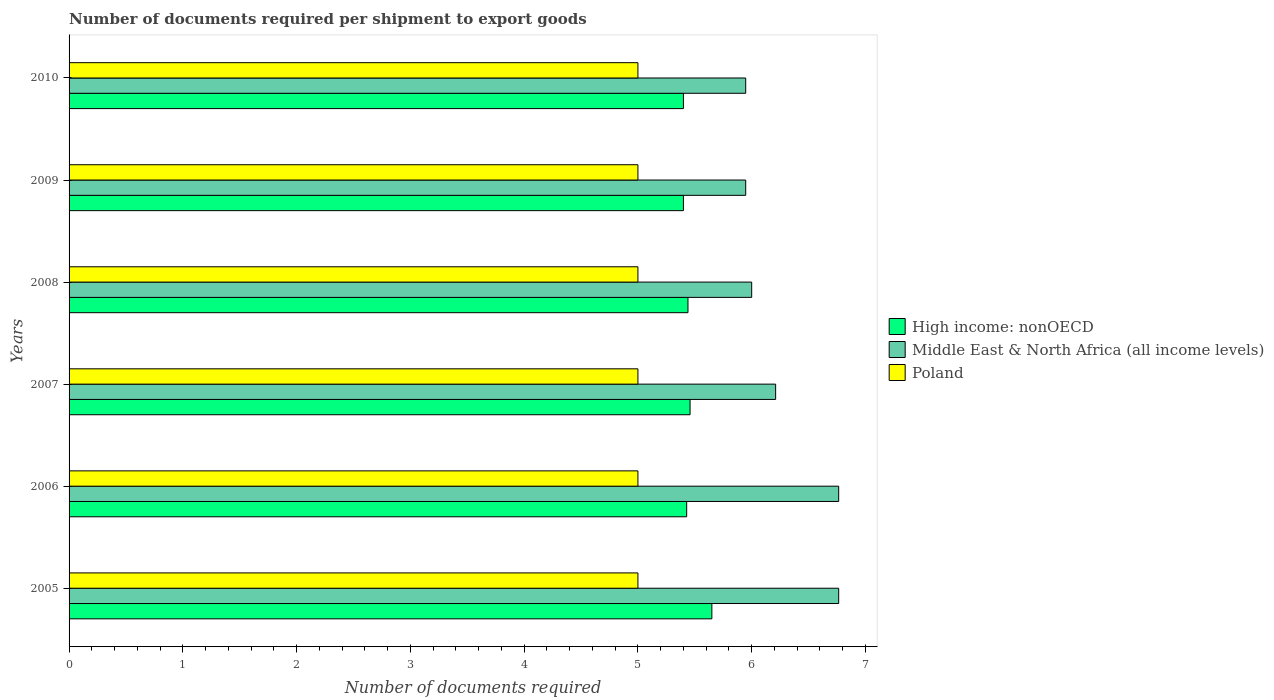How many groups of bars are there?
Your answer should be very brief. 6. Are the number of bars on each tick of the Y-axis equal?
Make the answer very short. Yes. How many bars are there on the 1st tick from the bottom?
Provide a succinct answer. 3. What is the number of documents required per shipment to export goods in High income: nonOECD in 2005?
Provide a short and direct response. 5.65. Across all years, what is the maximum number of documents required per shipment to export goods in Middle East & North Africa (all income levels)?
Your response must be concise. 6.76. Across all years, what is the minimum number of documents required per shipment to export goods in Poland?
Make the answer very short. 5. What is the total number of documents required per shipment to export goods in High income: nonOECD in the graph?
Your response must be concise. 32.78. What is the difference between the number of documents required per shipment to export goods in Poland in 2010 and the number of documents required per shipment to export goods in High income: nonOECD in 2005?
Your response must be concise. -0.65. What is the average number of documents required per shipment to export goods in High income: nonOECD per year?
Your answer should be compact. 5.46. In the year 2008, what is the difference between the number of documents required per shipment to export goods in High income: nonOECD and number of documents required per shipment to export goods in Middle East & North Africa (all income levels)?
Offer a very short reply. -0.56. What is the ratio of the number of documents required per shipment to export goods in Middle East & North Africa (all income levels) in 2007 to that in 2008?
Make the answer very short. 1.04. Is the sum of the number of documents required per shipment to export goods in Poland in 2006 and 2009 greater than the maximum number of documents required per shipment to export goods in Middle East & North Africa (all income levels) across all years?
Offer a very short reply. Yes. Is it the case that in every year, the sum of the number of documents required per shipment to export goods in Middle East & North Africa (all income levels) and number of documents required per shipment to export goods in Poland is greater than the number of documents required per shipment to export goods in High income: nonOECD?
Offer a terse response. Yes. Are all the bars in the graph horizontal?
Provide a short and direct response. Yes. How many years are there in the graph?
Provide a succinct answer. 6. Does the graph contain grids?
Offer a terse response. No. How many legend labels are there?
Provide a succinct answer. 3. What is the title of the graph?
Give a very brief answer. Number of documents required per shipment to export goods. Does "Seychelles" appear as one of the legend labels in the graph?
Your answer should be compact. No. What is the label or title of the X-axis?
Your answer should be compact. Number of documents required. What is the Number of documents required in High income: nonOECD in 2005?
Provide a short and direct response. 5.65. What is the Number of documents required in Middle East & North Africa (all income levels) in 2005?
Offer a terse response. 6.76. What is the Number of documents required in Poland in 2005?
Provide a short and direct response. 5. What is the Number of documents required of High income: nonOECD in 2006?
Your answer should be compact. 5.43. What is the Number of documents required in Middle East & North Africa (all income levels) in 2006?
Your answer should be very brief. 6.76. What is the Number of documents required of Poland in 2006?
Your response must be concise. 5. What is the Number of documents required of High income: nonOECD in 2007?
Provide a succinct answer. 5.46. What is the Number of documents required of Middle East & North Africa (all income levels) in 2007?
Give a very brief answer. 6.21. What is the Number of documents required in Poland in 2007?
Ensure brevity in your answer.  5. What is the Number of documents required in High income: nonOECD in 2008?
Give a very brief answer. 5.44. What is the Number of documents required of High income: nonOECD in 2009?
Offer a very short reply. 5.4. What is the Number of documents required in Middle East & North Africa (all income levels) in 2009?
Offer a very short reply. 5.95. What is the Number of documents required in Poland in 2009?
Offer a terse response. 5. What is the Number of documents required of Middle East & North Africa (all income levels) in 2010?
Give a very brief answer. 5.95. What is the Number of documents required of Poland in 2010?
Make the answer very short. 5. Across all years, what is the maximum Number of documents required in High income: nonOECD?
Your answer should be compact. 5.65. Across all years, what is the maximum Number of documents required in Middle East & North Africa (all income levels)?
Your answer should be very brief. 6.76. Across all years, what is the maximum Number of documents required in Poland?
Ensure brevity in your answer.  5. Across all years, what is the minimum Number of documents required in High income: nonOECD?
Offer a very short reply. 5.4. Across all years, what is the minimum Number of documents required in Middle East & North Africa (all income levels)?
Your answer should be very brief. 5.95. What is the total Number of documents required of High income: nonOECD in the graph?
Your response must be concise. 32.78. What is the total Number of documents required of Middle East & North Africa (all income levels) in the graph?
Offer a very short reply. 37.63. What is the difference between the Number of documents required in High income: nonOECD in 2005 and that in 2006?
Provide a succinct answer. 0.22. What is the difference between the Number of documents required of High income: nonOECD in 2005 and that in 2007?
Ensure brevity in your answer.  0.19. What is the difference between the Number of documents required in Middle East & North Africa (all income levels) in 2005 and that in 2007?
Your answer should be compact. 0.55. What is the difference between the Number of documents required of High income: nonOECD in 2005 and that in 2008?
Give a very brief answer. 0.21. What is the difference between the Number of documents required of Middle East & North Africa (all income levels) in 2005 and that in 2008?
Your answer should be very brief. 0.76. What is the difference between the Number of documents required in High income: nonOECD in 2005 and that in 2009?
Make the answer very short. 0.25. What is the difference between the Number of documents required of Middle East & North Africa (all income levels) in 2005 and that in 2009?
Your response must be concise. 0.82. What is the difference between the Number of documents required in Poland in 2005 and that in 2009?
Provide a succinct answer. 0. What is the difference between the Number of documents required of High income: nonOECD in 2005 and that in 2010?
Make the answer very short. 0.25. What is the difference between the Number of documents required of Middle East & North Africa (all income levels) in 2005 and that in 2010?
Your answer should be very brief. 0.82. What is the difference between the Number of documents required of High income: nonOECD in 2006 and that in 2007?
Provide a succinct answer. -0.03. What is the difference between the Number of documents required in Middle East & North Africa (all income levels) in 2006 and that in 2007?
Provide a succinct answer. 0.55. What is the difference between the Number of documents required of High income: nonOECD in 2006 and that in 2008?
Provide a short and direct response. -0.01. What is the difference between the Number of documents required of Middle East & North Africa (all income levels) in 2006 and that in 2008?
Your response must be concise. 0.76. What is the difference between the Number of documents required in High income: nonOECD in 2006 and that in 2009?
Your response must be concise. 0.03. What is the difference between the Number of documents required of Middle East & North Africa (all income levels) in 2006 and that in 2009?
Provide a succinct answer. 0.82. What is the difference between the Number of documents required of High income: nonOECD in 2006 and that in 2010?
Your response must be concise. 0.03. What is the difference between the Number of documents required in Middle East & North Africa (all income levels) in 2006 and that in 2010?
Your response must be concise. 0.82. What is the difference between the Number of documents required of Poland in 2006 and that in 2010?
Your answer should be compact. 0. What is the difference between the Number of documents required in High income: nonOECD in 2007 and that in 2008?
Your answer should be very brief. 0.02. What is the difference between the Number of documents required of Middle East & North Africa (all income levels) in 2007 and that in 2008?
Offer a very short reply. 0.21. What is the difference between the Number of documents required of High income: nonOECD in 2007 and that in 2009?
Your answer should be very brief. 0.06. What is the difference between the Number of documents required of Middle East & North Africa (all income levels) in 2007 and that in 2009?
Your answer should be compact. 0.26. What is the difference between the Number of documents required in High income: nonOECD in 2007 and that in 2010?
Your answer should be very brief. 0.06. What is the difference between the Number of documents required in Middle East & North Africa (all income levels) in 2007 and that in 2010?
Offer a terse response. 0.26. What is the difference between the Number of documents required of Poland in 2007 and that in 2010?
Keep it short and to the point. 0. What is the difference between the Number of documents required in Middle East & North Africa (all income levels) in 2008 and that in 2009?
Give a very brief answer. 0.05. What is the difference between the Number of documents required of High income: nonOECD in 2008 and that in 2010?
Provide a succinct answer. 0.04. What is the difference between the Number of documents required of Middle East & North Africa (all income levels) in 2008 and that in 2010?
Ensure brevity in your answer.  0.05. What is the difference between the Number of documents required in Poland in 2008 and that in 2010?
Your answer should be compact. 0. What is the difference between the Number of documents required in High income: nonOECD in 2005 and the Number of documents required in Middle East & North Africa (all income levels) in 2006?
Offer a very short reply. -1.11. What is the difference between the Number of documents required in High income: nonOECD in 2005 and the Number of documents required in Poland in 2006?
Your answer should be compact. 0.65. What is the difference between the Number of documents required of Middle East & North Africa (all income levels) in 2005 and the Number of documents required of Poland in 2006?
Make the answer very short. 1.76. What is the difference between the Number of documents required in High income: nonOECD in 2005 and the Number of documents required in Middle East & North Africa (all income levels) in 2007?
Offer a terse response. -0.56. What is the difference between the Number of documents required in High income: nonOECD in 2005 and the Number of documents required in Poland in 2007?
Provide a succinct answer. 0.65. What is the difference between the Number of documents required of Middle East & North Africa (all income levels) in 2005 and the Number of documents required of Poland in 2007?
Give a very brief answer. 1.76. What is the difference between the Number of documents required of High income: nonOECD in 2005 and the Number of documents required of Middle East & North Africa (all income levels) in 2008?
Provide a short and direct response. -0.35. What is the difference between the Number of documents required of High income: nonOECD in 2005 and the Number of documents required of Poland in 2008?
Provide a succinct answer. 0.65. What is the difference between the Number of documents required in Middle East & North Africa (all income levels) in 2005 and the Number of documents required in Poland in 2008?
Your answer should be compact. 1.76. What is the difference between the Number of documents required of High income: nonOECD in 2005 and the Number of documents required of Middle East & North Africa (all income levels) in 2009?
Offer a very short reply. -0.3. What is the difference between the Number of documents required of High income: nonOECD in 2005 and the Number of documents required of Poland in 2009?
Provide a succinct answer. 0.65. What is the difference between the Number of documents required in Middle East & North Africa (all income levels) in 2005 and the Number of documents required in Poland in 2009?
Make the answer very short. 1.76. What is the difference between the Number of documents required in High income: nonOECD in 2005 and the Number of documents required in Middle East & North Africa (all income levels) in 2010?
Provide a succinct answer. -0.3. What is the difference between the Number of documents required in High income: nonOECD in 2005 and the Number of documents required in Poland in 2010?
Keep it short and to the point. 0.65. What is the difference between the Number of documents required in Middle East & North Africa (all income levels) in 2005 and the Number of documents required in Poland in 2010?
Keep it short and to the point. 1.76. What is the difference between the Number of documents required in High income: nonOECD in 2006 and the Number of documents required in Middle East & North Africa (all income levels) in 2007?
Offer a very short reply. -0.78. What is the difference between the Number of documents required in High income: nonOECD in 2006 and the Number of documents required in Poland in 2007?
Offer a terse response. 0.43. What is the difference between the Number of documents required in Middle East & North Africa (all income levels) in 2006 and the Number of documents required in Poland in 2007?
Provide a succinct answer. 1.76. What is the difference between the Number of documents required of High income: nonOECD in 2006 and the Number of documents required of Middle East & North Africa (all income levels) in 2008?
Your response must be concise. -0.57. What is the difference between the Number of documents required of High income: nonOECD in 2006 and the Number of documents required of Poland in 2008?
Provide a short and direct response. 0.43. What is the difference between the Number of documents required of Middle East & North Africa (all income levels) in 2006 and the Number of documents required of Poland in 2008?
Provide a succinct answer. 1.76. What is the difference between the Number of documents required of High income: nonOECD in 2006 and the Number of documents required of Middle East & North Africa (all income levels) in 2009?
Offer a terse response. -0.52. What is the difference between the Number of documents required in High income: nonOECD in 2006 and the Number of documents required in Poland in 2009?
Keep it short and to the point. 0.43. What is the difference between the Number of documents required of Middle East & North Africa (all income levels) in 2006 and the Number of documents required of Poland in 2009?
Offer a very short reply. 1.76. What is the difference between the Number of documents required of High income: nonOECD in 2006 and the Number of documents required of Middle East & North Africa (all income levels) in 2010?
Make the answer very short. -0.52. What is the difference between the Number of documents required in High income: nonOECD in 2006 and the Number of documents required in Poland in 2010?
Offer a terse response. 0.43. What is the difference between the Number of documents required in Middle East & North Africa (all income levels) in 2006 and the Number of documents required in Poland in 2010?
Your answer should be compact. 1.76. What is the difference between the Number of documents required of High income: nonOECD in 2007 and the Number of documents required of Middle East & North Africa (all income levels) in 2008?
Ensure brevity in your answer.  -0.54. What is the difference between the Number of documents required in High income: nonOECD in 2007 and the Number of documents required in Poland in 2008?
Offer a very short reply. 0.46. What is the difference between the Number of documents required of Middle East & North Africa (all income levels) in 2007 and the Number of documents required of Poland in 2008?
Your answer should be compact. 1.21. What is the difference between the Number of documents required of High income: nonOECD in 2007 and the Number of documents required of Middle East & North Africa (all income levels) in 2009?
Keep it short and to the point. -0.49. What is the difference between the Number of documents required of High income: nonOECD in 2007 and the Number of documents required of Poland in 2009?
Keep it short and to the point. 0.46. What is the difference between the Number of documents required of Middle East & North Africa (all income levels) in 2007 and the Number of documents required of Poland in 2009?
Your response must be concise. 1.21. What is the difference between the Number of documents required in High income: nonOECD in 2007 and the Number of documents required in Middle East & North Africa (all income levels) in 2010?
Your answer should be compact. -0.49. What is the difference between the Number of documents required of High income: nonOECD in 2007 and the Number of documents required of Poland in 2010?
Offer a very short reply. 0.46. What is the difference between the Number of documents required of Middle East & North Africa (all income levels) in 2007 and the Number of documents required of Poland in 2010?
Your answer should be compact. 1.21. What is the difference between the Number of documents required in High income: nonOECD in 2008 and the Number of documents required in Middle East & North Africa (all income levels) in 2009?
Offer a very short reply. -0.51. What is the difference between the Number of documents required of High income: nonOECD in 2008 and the Number of documents required of Poland in 2009?
Give a very brief answer. 0.44. What is the difference between the Number of documents required of High income: nonOECD in 2008 and the Number of documents required of Middle East & North Africa (all income levels) in 2010?
Your response must be concise. -0.51. What is the difference between the Number of documents required in High income: nonOECD in 2008 and the Number of documents required in Poland in 2010?
Provide a short and direct response. 0.44. What is the difference between the Number of documents required in High income: nonOECD in 2009 and the Number of documents required in Middle East & North Africa (all income levels) in 2010?
Offer a terse response. -0.55. What is the difference between the Number of documents required of High income: nonOECD in 2009 and the Number of documents required of Poland in 2010?
Offer a very short reply. 0.4. What is the difference between the Number of documents required in Middle East & North Africa (all income levels) in 2009 and the Number of documents required in Poland in 2010?
Offer a very short reply. 0.95. What is the average Number of documents required of High income: nonOECD per year?
Make the answer very short. 5.46. What is the average Number of documents required in Middle East & North Africa (all income levels) per year?
Provide a short and direct response. 6.27. What is the average Number of documents required of Poland per year?
Provide a succinct answer. 5. In the year 2005, what is the difference between the Number of documents required in High income: nonOECD and Number of documents required in Middle East & North Africa (all income levels)?
Provide a short and direct response. -1.11. In the year 2005, what is the difference between the Number of documents required of High income: nonOECD and Number of documents required of Poland?
Offer a very short reply. 0.65. In the year 2005, what is the difference between the Number of documents required in Middle East & North Africa (all income levels) and Number of documents required in Poland?
Make the answer very short. 1.76. In the year 2006, what is the difference between the Number of documents required of High income: nonOECD and Number of documents required of Middle East & North Africa (all income levels)?
Ensure brevity in your answer.  -1.34. In the year 2006, what is the difference between the Number of documents required of High income: nonOECD and Number of documents required of Poland?
Your answer should be very brief. 0.43. In the year 2006, what is the difference between the Number of documents required in Middle East & North Africa (all income levels) and Number of documents required in Poland?
Give a very brief answer. 1.76. In the year 2007, what is the difference between the Number of documents required in High income: nonOECD and Number of documents required in Middle East & North Africa (all income levels)?
Offer a very short reply. -0.75. In the year 2007, what is the difference between the Number of documents required of High income: nonOECD and Number of documents required of Poland?
Offer a very short reply. 0.46. In the year 2007, what is the difference between the Number of documents required of Middle East & North Africa (all income levels) and Number of documents required of Poland?
Keep it short and to the point. 1.21. In the year 2008, what is the difference between the Number of documents required in High income: nonOECD and Number of documents required in Middle East & North Africa (all income levels)?
Your answer should be very brief. -0.56. In the year 2008, what is the difference between the Number of documents required of High income: nonOECD and Number of documents required of Poland?
Make the answer very short. 0.44. In the year 2008, what is the difference between the Number of documents required in Middle East & North Africa (all income levels) and Number of documents required in Poland?
Your answer should be very brief. 1. In the year 2009, what is the difference between the Number of documents required of High income: nonOECD and Number of documents required of Middle East & North Africa (all income levels)?
Offer a terse response. -0.55. In the year 2009, what is the difference between the Number of documents required of Middle East & North Africa (all income levels) and Number of documents required of Poland?
Offer a terse response. 0.95. In the year 2010, what is the difference between the Number of documents required in High income: nonOECD and Number of documents required in Middle East & North Africa (all income levels)?
Offer a very short reply. -0.55. In the year 2010, what is the difference between the Number of documents required of High income: nonOECD and Number of documents required of Poland?
Provide a succinct answer. 0.4. In the year 2010, what is the difference between the Number of documents required of Middle East & North Africa (all income levels) and Number of documents required of Poland?
Offer a very short reply. 0.95. What is the ratio of the Number of documents required in High income: nonOECD in 2005 to that in 2006?
Your answer should be very brief. 1.04. What is the ratio of the Number of documents required in High income: nonOECD in 2005 to that in 2007?
Your answer should be very brief. 1.04. What is the ratio of the Number of documents required of Middle East & North Africa (all income levels) in 2005 to that in 2007?
Provide a short and direct response. 1.09. What is the ratio of the Number of documents required in Poland in 2005 to that in 2007?
Provide a short and direct response. 1. What is the ratio of the Number of documents required of High income: nonOECD in 2005 to that in 2008?
Offer a very short reply. 1.04. What is the ratio of the Number of documents required in Middle East & North Africa (all income levels) in 2005 to that in 2008?
Offer a very short reply. 1.13. What is the ratio of the Number of documents required in Poland in 2005 to that in 2008?
Ensure brevity in your answer.  1. What is the ratio of the Number of documents required in High income: nonOECD in 2005 to that in 2009?
Offer a very short reply. 1.05. What is the ratio of the Number of documents required in Middle East & North Africa (all income levels) in 2005 to that in 2009?
Provide a succinct answer. 1.14. What is the ratio of the Number of documents required in High income: nonOECD in 2005 to that in 2010?
Offer a very short reply. 1.05. What is the ratio of the Number of documents required of Middle East & North Africa (all income levels) in 2005 to that in 2010?
Offer a terse response. 1.14. What is the ratio of the Number of documents required in Poland in 2005 to that in 2010?
Your answer should be very brief. 1. What is the ratio of the Number of documents required of High income: nonOECD in 2006 to that in 2007?
Offer a terse response. 0.99. What is the ratio of the Number of documents required in Middle East & North Africa (all income levels) in 2006 to that in 2007?
Provide a succinct answer. 1.09. What is the ratio of the Number of documents required of Poland in 2006 to that in 2007?
Give a very brief answer. 1. What is the ratio of the Number of documents required in Middle East & North Africa (all income levels) in 2006 to that in 2008?
Provide a short and direct response. 1.13. What is the ratio of the Number of documents required in High income: nonOECD in 2006 to that in 2009?
Offer a very short reply. 1.01. What is the ratio of the Number of documents required in Middle East & North Africa (all income levels) in 2006 to that in 2009?
Offer a terse response. 1.14. What is the ratio of the Number of documents required of Poland in 2006 to that in 2009?
Keep it short and to the point. 1. What is the ratio of the Number of documents required of Middle East & North Africa (all income levels) in 2006 to that in 2010?
Give a very brief answer. 1.14. What is the ratio of the Number of documents required of Poland in 2006 to that in 2010?
Make the answer very short. 1. What is the ratio of the Number of documents required in High income: nonOECD in 2007 to that in 2008?
Your answer should be compact. 1. What is the ratio of the Number of documents required of Middle East & North Africa (all income levels) in 2007 to that in 2008?
Make the answer very short. 1.04. What is the ratio of the Number of documents required of Poland in 2007 to that in 2008?
Offer a terse response. 1. What is the ratio of the Number of documents required in High income: nonOECD in 2007 to that in 2009?
Make the answer very short. 1.01. What is the ratio of the Number of documents required in Middle East & North Africa (all income levels) in 2007 to that in 2009?
Your answer should be compact. 1.04. What is the ratio of the Number of documents required of High income: nonOECD in 2007 to that in 2010?
Ensure brevity in your answer.  1.01. What is the ratio of the Number of documents required of Middle East & North Africa (all income levels) in 2007 to that in 2010?
Give a very brief answer. 1.04. What is the ratio of the Number of documents required of Poland in 2007 to that in 2010?
Offer a terse response. 1. What is the ratio of the Number of documents required of High income: nonOECD in 2008 to that in 2009?
Give a very brief answer. 1.01. What is the ratio of the Number of documents required in Middle East & North Africa (all income levels) in 2008 to that in 2009?
Provide a short and direct response. 1.01. What is the ratio of the Number of documents required in Poland in 2008 to that in 2009?
Ensure brevity in your answer.  1. What is the ratio of the Number of documents required in High income: nonOECD in 2008 to that in 2010?
Offer a terse response. 1.01. What is the ratio of the Number of documents required of Middle East & North Africa (all income levels) in 2008 to that in 2010?
Give a very brief answer. 1.01. What is the ratio of the Number of documents required of Poland in 2009 to that in 2010?
Provide a short and direct response. 1. What is the difference between the highest and the second highest Number of documents required in High income: nonOECD?
Your answer should be very brief. 0.19. What is the difference between the highest and the lowest Number of documents required in Middle East & North Africa (all income levels)?
Offer a terse response. 0.82. 